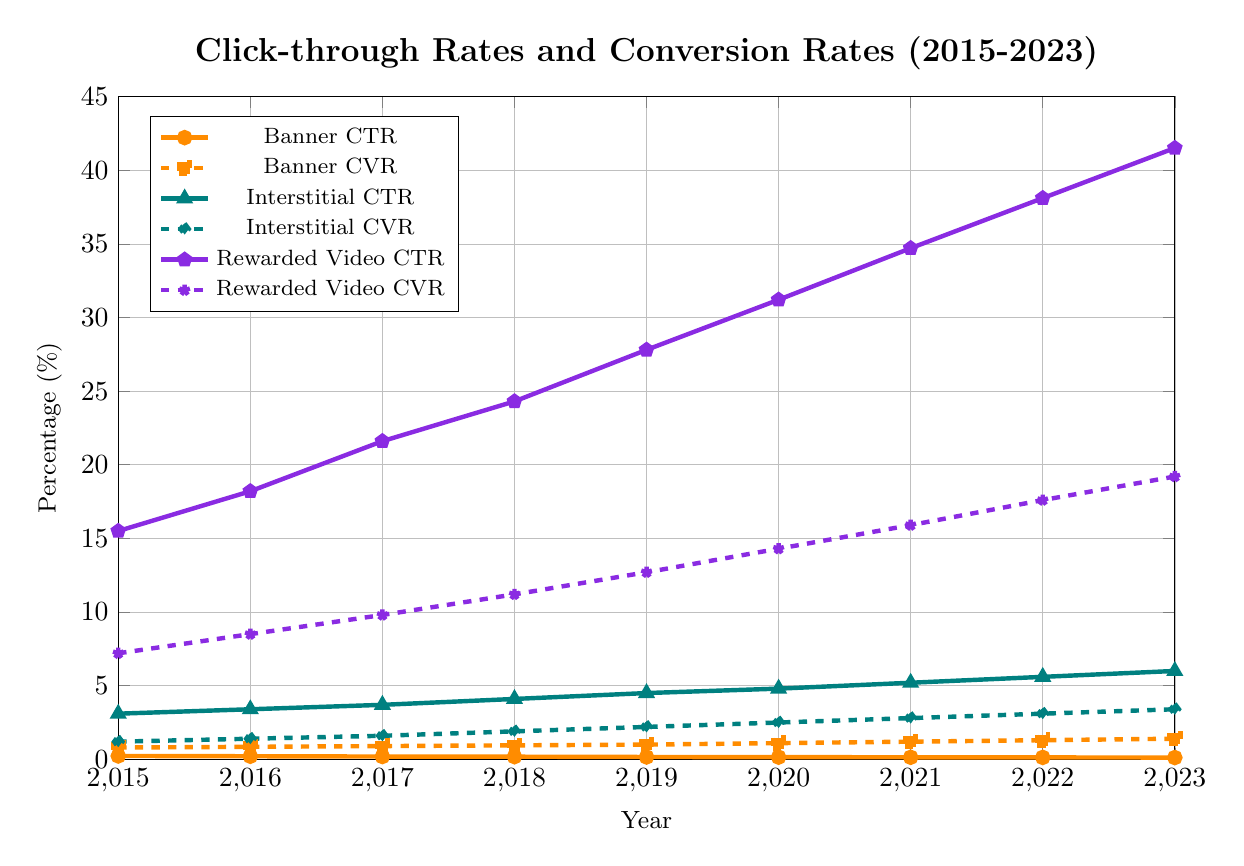Which ad format has the highest CTR in 2023? By looking at the plot, we can see that the rewarded video line is the highest on the CTR axis in 2023.
Answer: Rewarded video How has the Banner CTR changed from 2015 to 2023? From the plot, we see that the Banner CTR has decreased over time. It started at 0.23% in 2015 and dropped to 0.12% in 2023.
Answer: Decreased Compare the CVR of interstitial ads and rewarded videos in 2023. Which one is higher? In 2023, the CVR for interstitial ads is 3.4%, while for rewarded videos it is 19.2%. By comparing these values, we see that rewarded videos have a higher CVR.
Answer: Rewarded videos What is the difference in CTR between banner ads and interstitial ads in 2019? The CTR for banner ads in 2019 is 0.16%, and for interstitial ads, it is 4.5%. The difference is 4.5 - 0.16 = 4.34%.
Answer: 4.34% Calculate the average CVR for rewarded videos from 2015 to 2023. Add CVR values for rewarded videos from each year: 7.2% + 8.5% + 9.8% + 11.2% + 12.7% + 14.3% + 15.9% + 17.6% + 19.2% = 116.4%. Then divide by the number of years, which is 9. 116.4% / 9 = approximately 12.93%.
Answer: 12.93% Are there any years where the CTR for interstitial is less than 3%? By checking the plot, we see that in all years from 2015 to 2023, the interstitial CTR is above 3%.
Answer: No What is the difference in CVR for banner ads between 2015 and 2023? The CVR for banner ads is 0.8% in 2015 and 1.4% in 2023. The difference is 1.4% - 0.8% = 0.6%.
Answer: 0.6% In which year did rewarded video ads exceed a 30% CTR for the first time? By looking at the rewarded video CTR line, we see it exceeds 30% for the first time in 2020.
Answer: 2020 